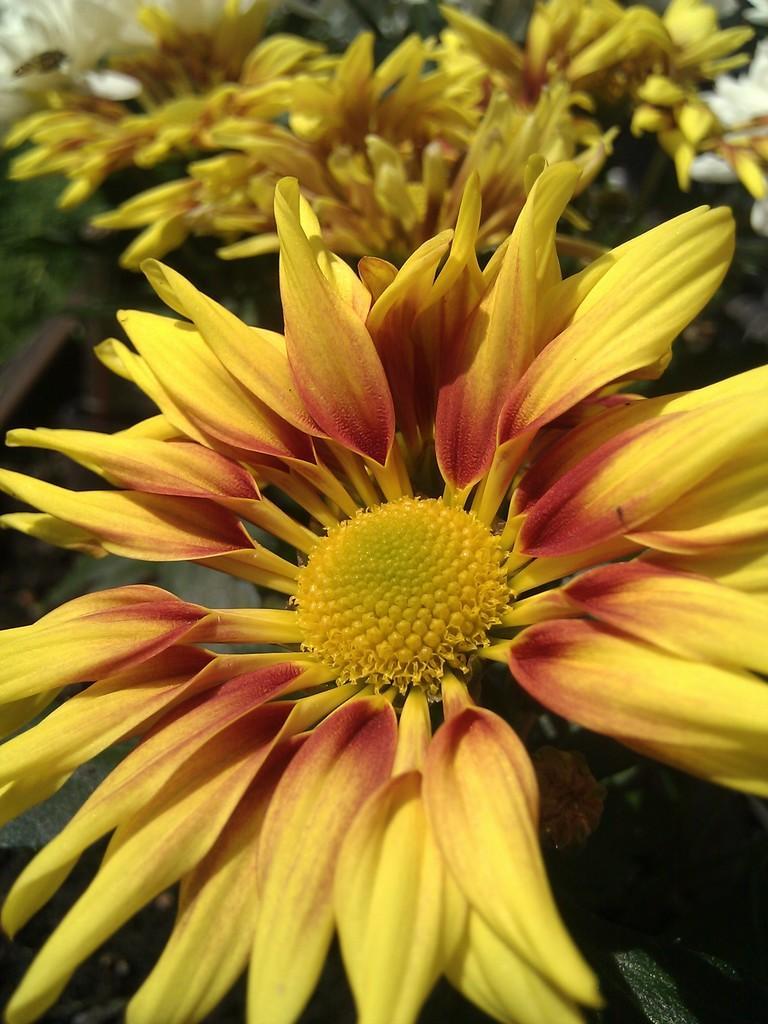Could you give a brief overview of what you see in this image? In this image I can see a flower which is yellow and red in color. In the background I can see few trees and few flowers which are cream and yellow in color. 